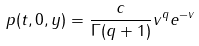<formula> <loc_0><loc_0><loc_500><loc_500>p ( t , 0 , y ) = \frac { c } { \Gamma ( q + 1 ) } v ^ { q } e ^ { - v }</formula> 